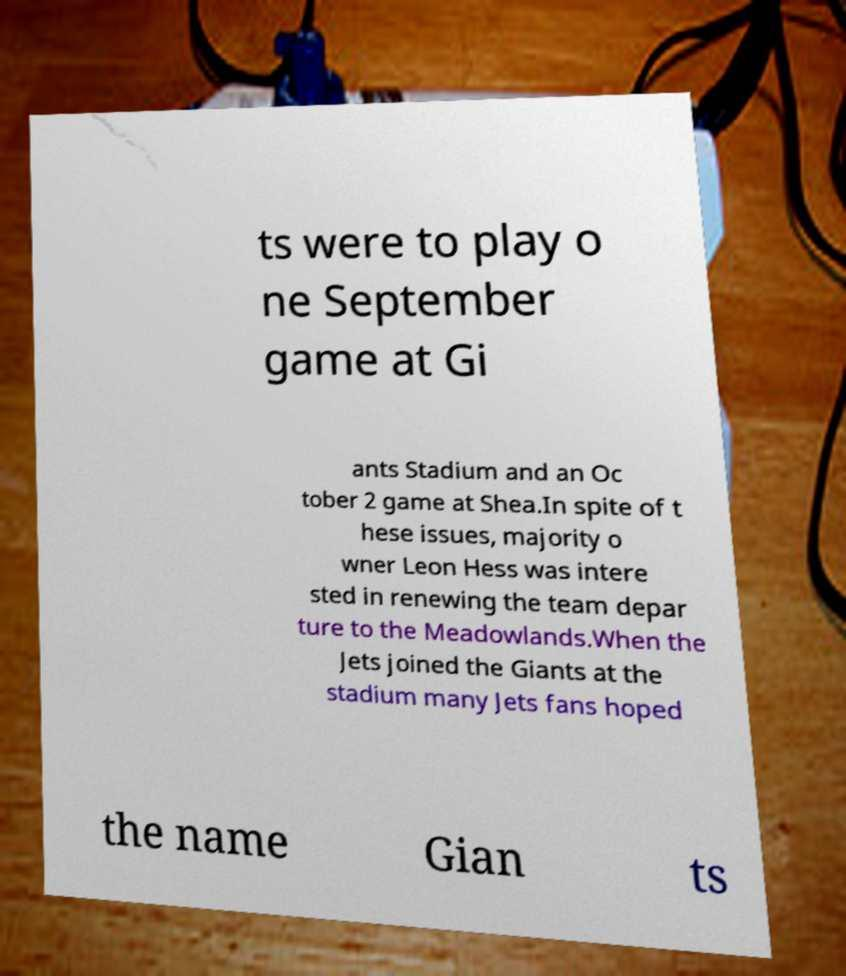Could you assist in decoding the text presented in this image and type it out clearly? ts were to play o ne September game at Gi ants Stadium and an Oc tober 2 game at Shea.In spite of t hese issues, majority o wner Leon Hess was intere sted in renewing the team depar ture to the Meadowlands.When the Jets joined the Giants at the stadium many Jets fans hoped the name Gian ts 